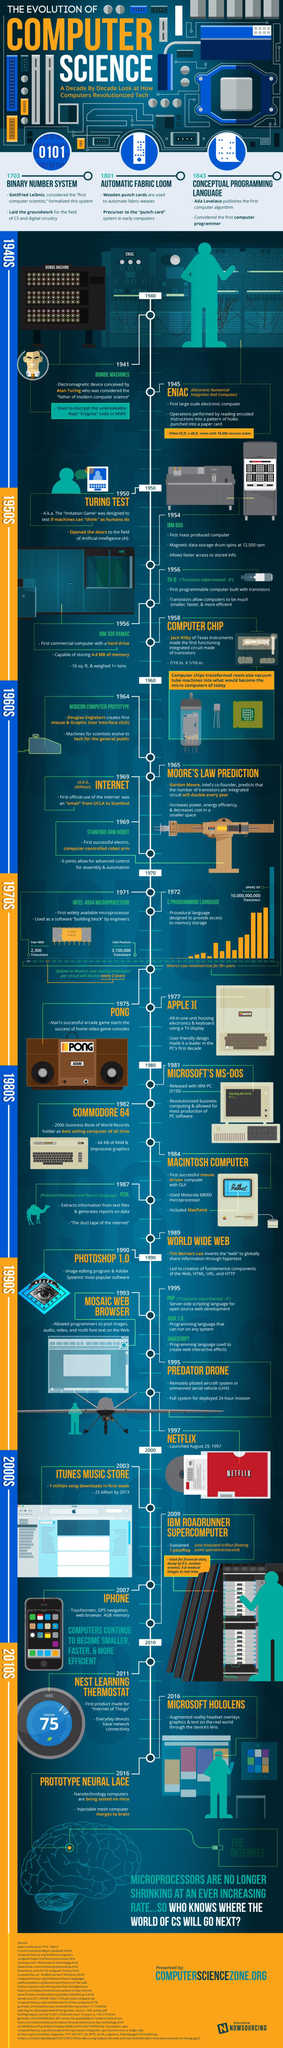Indicate a few pertinent items in this graphic. PHP was developed in 1995, as well as JAVA 1.0 and JAVASCRIPT. These languages have been widely used for programming purposes. The first integrated circuit chip was approximately 7/16 inches by 1/16 inches in size. The first IC chip was made in 1958. The C programming language was developed in 1972. The Commodore 64 has 64 kilobytes of random access memory. 